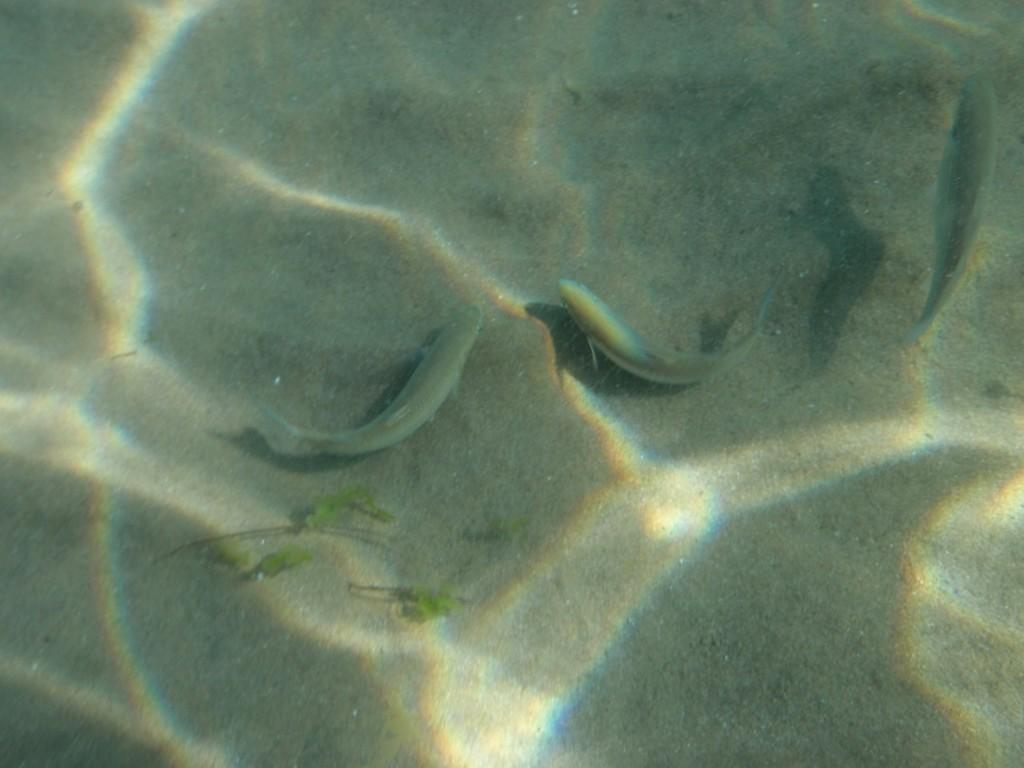What type of environment is depicted in the image? The image is an underwater picture. What type of vegetation can be seen in the image? There are green colored leaves in the image. What type of animals are present in the image? There are fish in the image. What type of bulb is used to light up the home in the image? There is no home or bulb present in the image, as it is an underwater picture featuring green leaves and fish. 